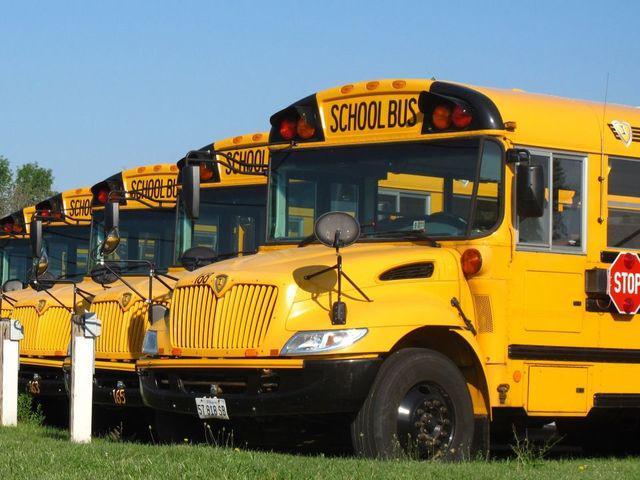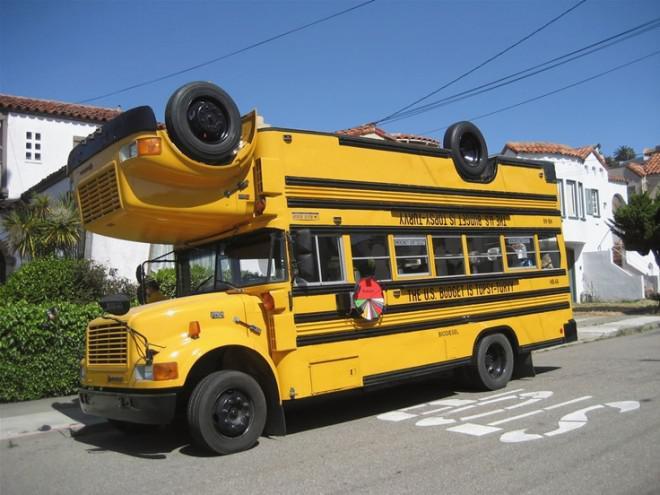The first image is the image on the left, the second image is the image on the right. Evaluate the accuracy of this statement regarding the images: "The buses on the left and right face opposite directions, and one has a flat front while the other has a hood that projects forward.". Is it true? Answer yes or no. No. 